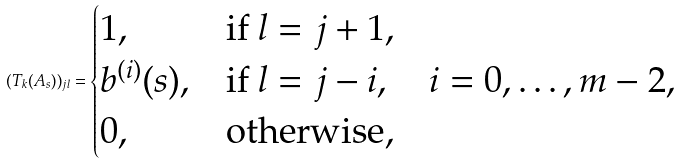Convert formula to latex. <formula><loc_0><loc_0><loc_500><loc_500>( T _ { k } ( A _ { s } ) ) _ { j l } = \begin{cases} 1 , & \text {if } l = j + 1 , \\ b ^ { ( i ) } ( s ) , & \text {if } l = j - i , \quad i = 0 , \dots , m - 2 , \\ 0 , & \text {otherwise} , \end{cases}</formula> 